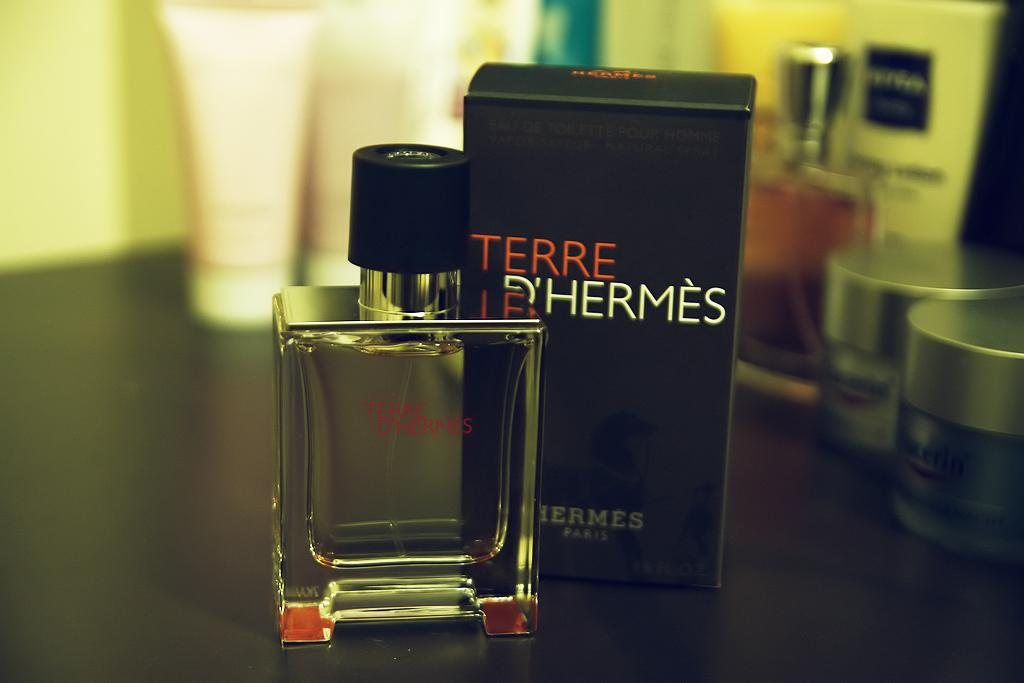Provide a one-sentence caption for the provided image. a bottle of Terre D'hermes perfume standing next to its box. 